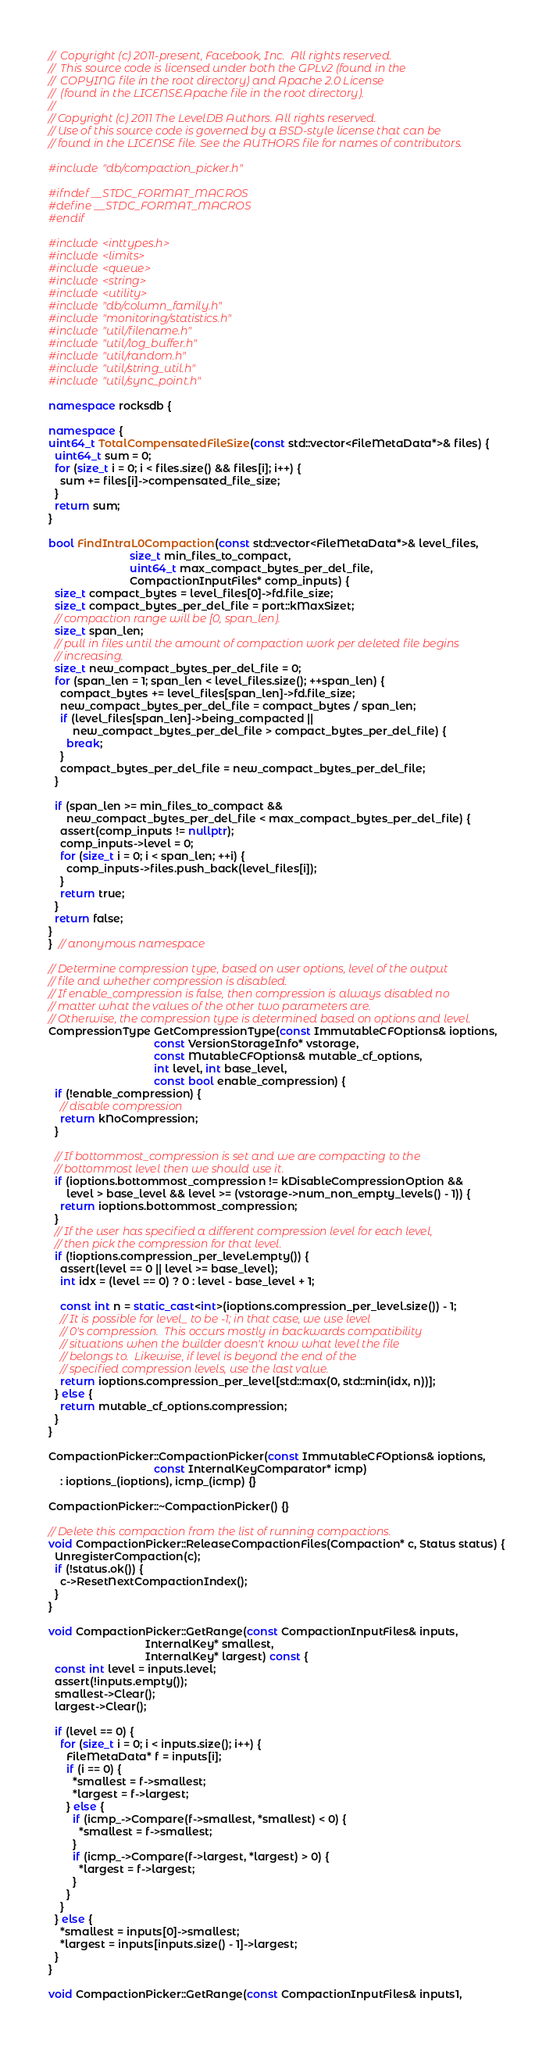<code> <loc_0><loc_0><loc_500><loc_500><_C++_>//  Copyright (c) 2011-present, Facebook, Inc.  All rights reserved.
//  This source code is licensed under both the GPLv2 (found in the
//  COPYING file in the root directory) and Apache 2.0 License
//  (found in the LICENSE.Apache file in the root directory).
//
// Copyright (c) 2011 The LevelDB Authors. All rights reserved.
// Use of this source code is governed by a BSD-style license that can be
// found in the LICENSE file. See the AUTHORS file for names of contributors.

#include "db/compaction_picker.h"

#ifndef __STDC_FORMAT_MACROS
#define __STDC_FORMAT_MACROS
#endif

#include <inttypes.h>
#include <limits>
#include <queue>
#include <string>
#include <utility>
#include "db/column_family.h"
#include "monitoring/statistics.h"
#include "util/filename.h"
#include "util/log_buffer.h"
#include "util/random.h"
#include "util/string_util.h"
#include "util/sync_point.h"

namespace rocksdb {

namespace {
uint64_t TotalCompensatedFileSize(const std::vector<FileMetaData*>& files) {
  uint64_t sum = 0;
  for (size_t i = 0; i < files.size() && files[i]; i++) {
    sum += files[i]->compensated_file_size;
  }
  return sum;
}

bool FindIntraL0Compaction(const std::vector<FileMetaData*>& level_files,
                           size_t min_files_to_compact,
                           uint64_t max_compact_bytes_per_del_file,
                           CompactionInputFiles* comp_inputs) {
  size_t compact_bytes = level_files[0]->fd.file_size;
  size_t compact_bytes_per_del_file = port::kMaxSizet;
  // compaction range will be [0, span_len).
  size_t span_len;
  // pull in files until the amount of compaction work per deleted file begins
  // increasing.
  size_t new_compact_bytes_per_del_file = 0;
  for (span_len = 1; span_len < level_files.size(); ++span_len) {
    compact_bytes += level_files[span_len]->fd.file_size;
    new_compact_bytes_per_del_file = compact_bytes / span_len;
    if (level_files[span_len]->being_compacted ||
        new_compact_bytes_per_del_file > compact_bytes_per_del_file) {
      break;
    }
    compact_bytes_per_del_file = new_compact_bytes_per_del_file;
  }

  if (span_len >= min_files_to_compact &&
      new_compact_bytes_per_del_file < max_compact_bytes_per_del_file) {
    assert(comp_inputs != nullptr);
    comp_inputs->level = 0;
    for (size_t i = 0; i < span_len; ++i) {
      comp_inputs->files.push_back(level_files[i]);
    }
    return true;
  }
  return false;
}
}  // anonymous namespace

// Determine compression type, based on user options, level of the output
// file and whether compression is disabled.
// If enable_compression is false, then compression is always disabled no
// matter what the values of the other two parameters are.
// Otherwise, the compression type is determined based on options and level.
CompressionType GetCompressionType(const ImmutableCFOptions& ioptions,
                                   const VersionStorageInfo* vstorage,
                                   const MutableCFOptions& mutable_cf_options,
                                   int level, int base_level,
                                   const bool enable_compression) {
  if (!enable_compression) {
    // disable compression
    return kNoCompression;
  }

  // If bottommost_compression is set and we are compacting to the
  // bottommost level then we should use it.
  if (ioptions.bottommost_compression != kDisableCompressionOption &&
      level > base_level && level >= (vstorage->num_non_empty_levels() - 1)) {
    return ioptions.bottommost_compression;
  }
  // If the user has specified a different compression level for each level,
  // then pick the compression for that level.
  if (!ioptions.compression_per_level.empty()) {
    assert(level == 0 || level >= base_level);
    int idx = (level == 0) ? 0 : level - base_level + 1;

    const int n = static_cast<int>(ioptions.compression_per_level.size()) - 1;
    // It is possible for level_ to be -1; in that case, we use level
    // 0's compression.  This occurs mostly in backwards compatibility
    // situations when the builder doesn't know what level the file
    // belongs to.  Likewise, if level is beyond the end of the
    // specified compression levels, use the last value.
    return ioptions.compression_per_level[std::max(0, std::min(idx, n))];
  } else {
    return mutable_cf_options.compression;
  }
}

CompactionPicker::CompactionPicker(const ImmutableCFOptions& ioptions,
                                   const InternalKeyComparator* icmp)
    : ioptions_(ioptions), icmp_(icmp) {}

CompactionPicker::~CompactionPicker() {}

// Delete this compaction from the list of running compactions.
void CompactionPicker::ReleaseCompactionFiles(Compaction* c, Status status) {
  UnregisterCompaction(c);
  if (!status.ok()) {
    c->ResetNextCompactionIndex();
  }
}

void CompactionPicker::GetRange(const CompactionInputFiles& inputs,
                                InternalKey* smallest,
                                InternalKey* largest) const {
  const int level = inputs.level;
  assert(!inputs.empty());
  smallest->Clear();
  largest->Clear();

  if (level == 0) {
    for (size_t i = 0; i < inputs.size(); i++) {
      FileMetaData* f = inputs[i];
      if (i == 0) {
        *smallest = f->smallest;
        *largest = f->largest;
      } else {
        if (icmp_->Compare(f->smallest, *smallest) < 0) {
          *smallest = f->smallest;
        }
        if (icmp_->Compare(f->largest, *largest) > 0) {
          *largest = f->largest;
        }
      }
    }
  } else {
    *smallest = inputs[0]->smallest;
    *largest = inputs[inputs.size() - 1]->largest;
  }
}

void CompactionPicker::GetRange(const CompactionInputFiles& inputs1,</code> 